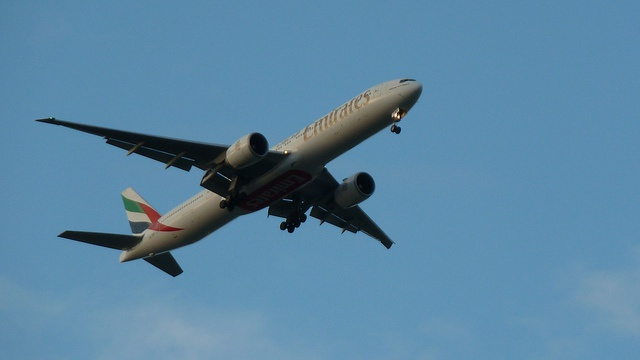Describe the objects in this image and their specific colors. I can see a airplane in gray, black, and darkgray tones in this image. 